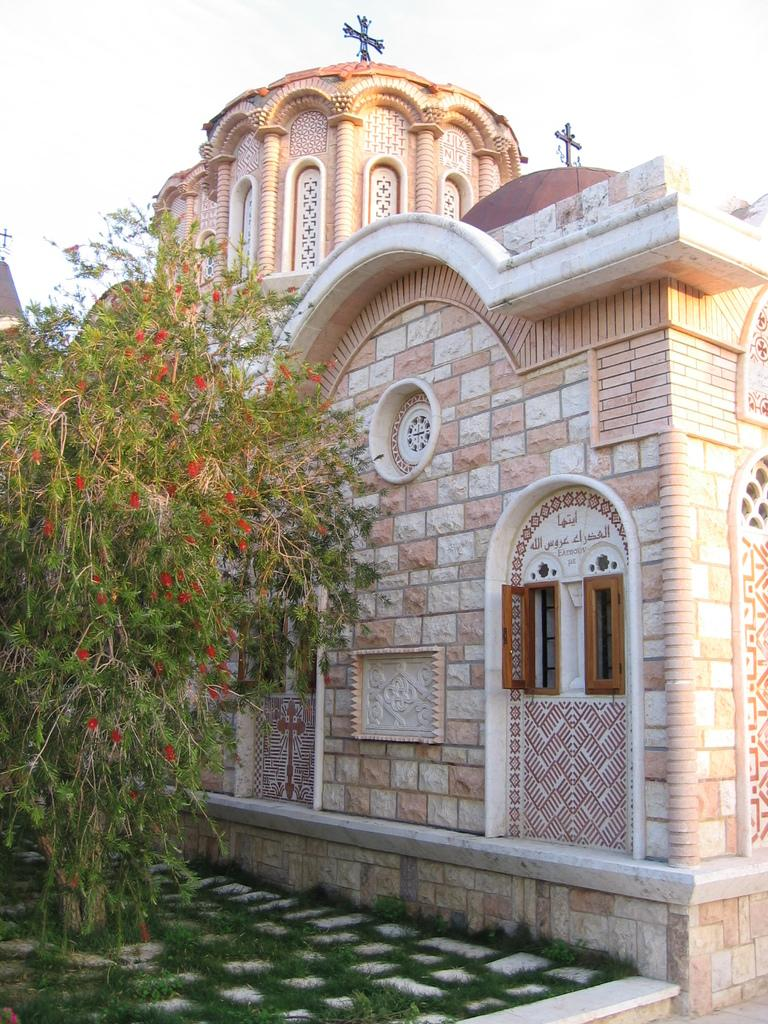What type of structure is present in the image? There is a building in the image. What can be seen near the building? There is a path in the image. What is the condition of the path? The path has green grass. What type of vegetation is present in the image? There are plants and red flowers in the image. What is visible in the background of the image? The sky is visible in the background of the image. What type of silk can be seen hanging from the building in the image? There is no silk present in the image; it features a building, a path, plants, and red flowers. How many houses are depicted in the image? The image does not show any houses; it features a building, a path, plants, and red flowers. 